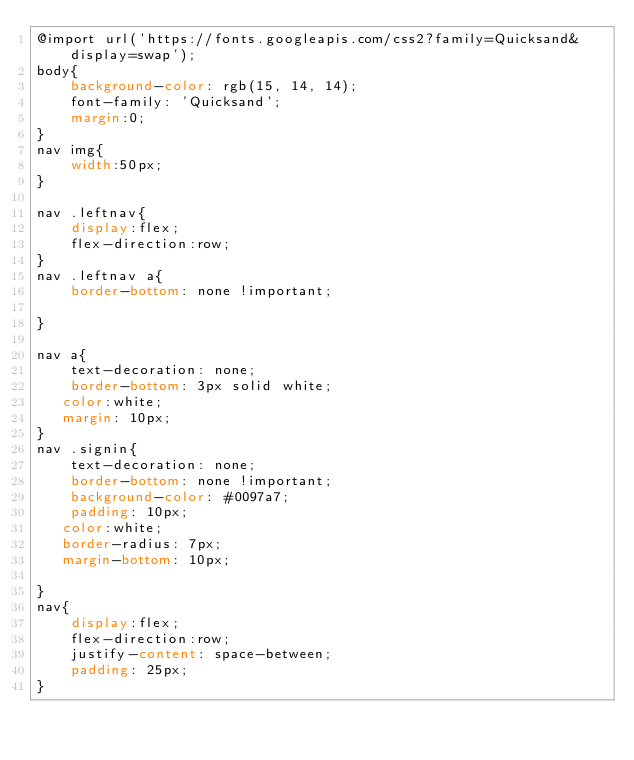<code> <loc_0><loc_0><loc_500><loc_500><_CSS_>@import url('https://fonts.googleapis.com/css2?family=Quicksand&display=swap');
body{
    background-color: rgb(15, 14, 14);
    font-family: 'Quicksand';
    margin:0;
}
nav img{
    width:50px;
}

nav .leftnav{
    display:flex;
    flex-direction:row;
}
nav .leftnav a{
    border-bottom: none !important;

}

nav a{
    text-decoration: none;
    border-bottom: 3px solid white;
   color:white;
   margin: 10px;
}
nav .signin{
    text-decoration: none;
    border-bottom: none !important;
    background-color: #0097a7;
    padding: 10px;
   color:white;
   border-radius: 7px;
   margin-bottom: 10px;

}
nav{
    display:flex;
    flex-direction:row;
    justify-content: space-between;
    padding: 25px;
}</code> 